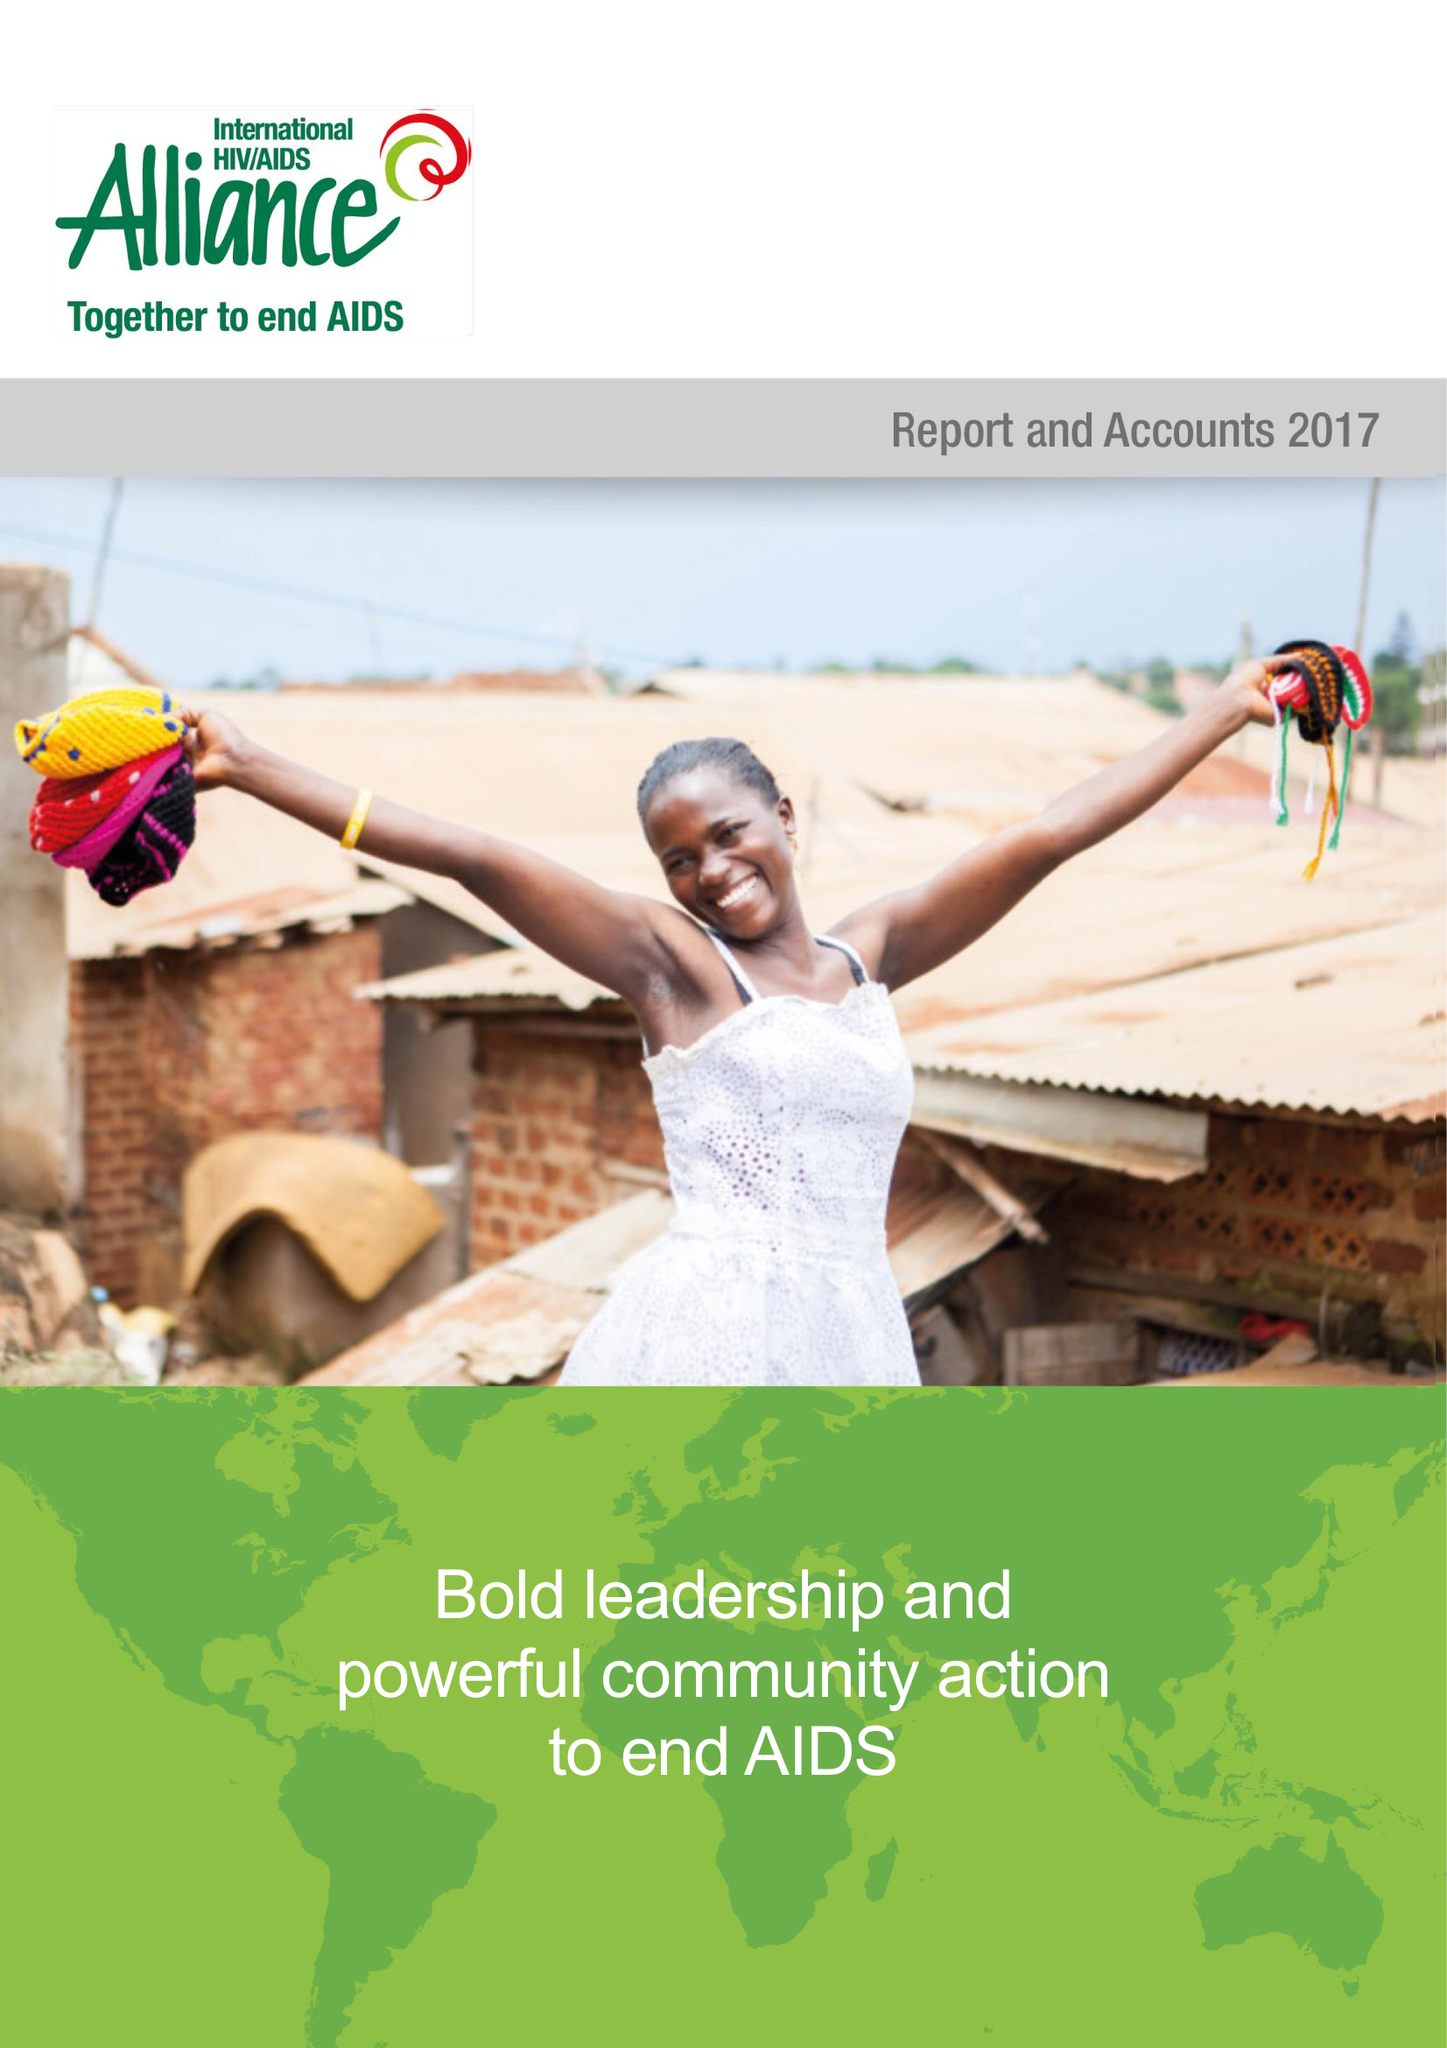What is the value for the charity_name?
Answer the question using a single word or phrase. Frontline Aids 